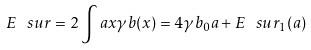Convert formula to latex. <formula><loc_0><loc_0><loc_500><loc_500>E ^ { \ } s u r = 2 \int a { x } \gamma b ( x ) = 4 \gamma b _ { 0 } a + E ^ { \ } s u r _ { 1 } ( a )</formula> 